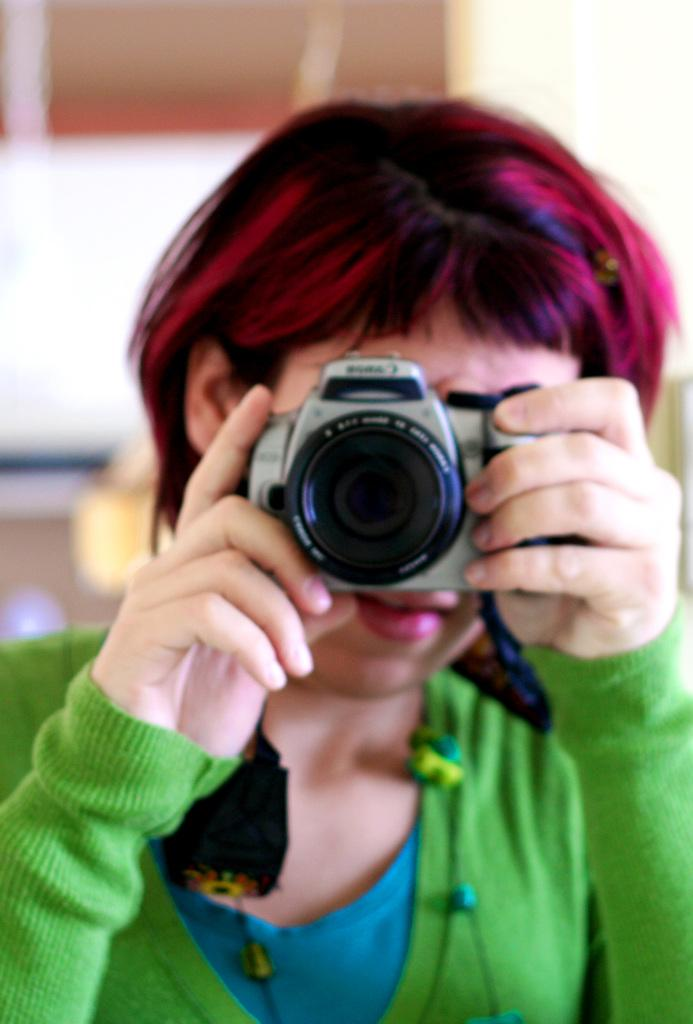Who is the main subject in the image? There is a lady in the image. What is the lady wearing? The lady is wearing a green dress. What is the lady holding in the image? The lady is holding a camera. What is the lady doing with the camera? The lady is capturing a picture. What type of smell is the lady trying to capture in the image? There is no indication of any smell in the image; it only shows the lady holding a camera and capturing a picture. 